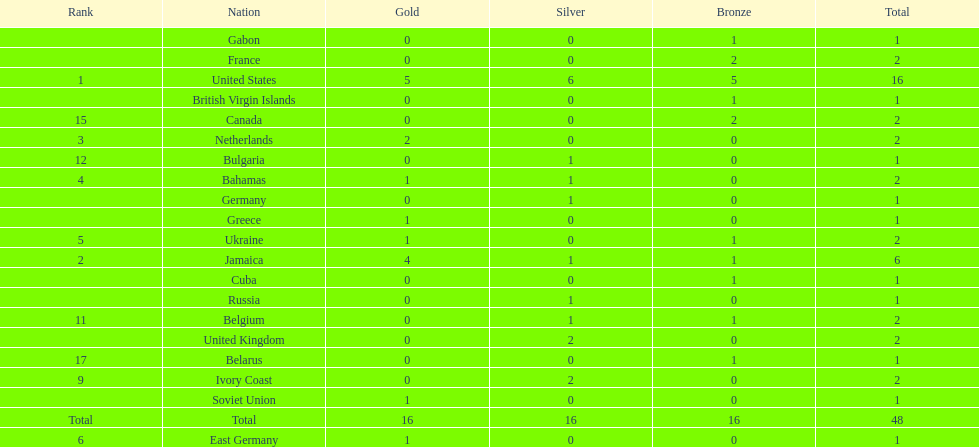How many nations won at least two gold medals? 3. 